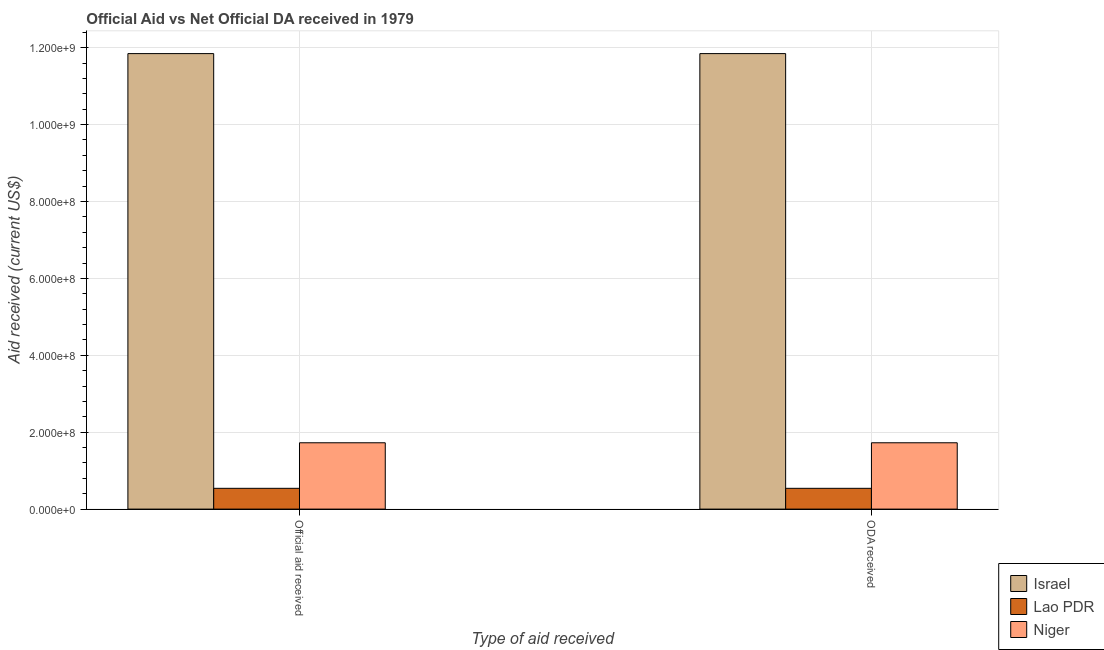How many different coloured bars are there?
Your answer should be compact. 3. How many groups of bars are there?
Your answer should be compact. 2. Are the number of bars per tick equal to the number of legend labels?
Ensure brevity in your answer.  Yes. How many bars are there on the 1st tick from the right?
Your answer should be very brief. 3. What is the label of the 2nd group of bars from the left?
Ensure brevity in your answer.  ODA received. What is the oda received in Lao PDR?
Give a very brief answer. 5.40e+07. Across all countries, what is the maximum official aid received?
Your response must be concise. 1.18e+09. Across all countries, what is the minimum official aid received?
Your answer should be compact. 5.40e+07. In which country was the official aid received maximum?
Give a very brief answer. Israel. In which country was the official aid received minimum?
Your response must be concise. Lao PDR. What is the total oda received in the graph?
Your answer should be compact. 1.41e+09. What is the difference between the oda received in Israel and that in Niger?
Your answer should be compact. 1.01e+09. What is the difference between the oda received in Israel and the official aid received in Niger?
Offer a very short reply. 1.01e+09. What is the average oda received per country?
Offer a very short reply. 4.70e+08. What is the ratio of the oda received in Niger to that in Israel?
Provide a succinct answer. 0.15. Is the oda received in Niger less than that in Lao PDR?
Your response must be concise. No. What does the 2nd bar from the right in Official aid received represents?
Keep it short and to the point. Lao PDR. Are all the bars in the graph horizontal?
Your answer should be very brief. No. Are the values on the major ticks of Y-axis written in scientific E-notation?
Keep it short and to the point. Yes. Does the graph contain grids?
Your answer should be compact. Yes. How are the legend labels stacked?
Keep it short and to the point. Vertical. What is the title of the graph?
Provide a short and direct response. Official Aid vs Net Official DA received in 1979 . What is the label or title of the X-axis?
Give a very brief answer. Type of aid received. What is the label or title of the Y-axis?
Your answer should be compact. Aid received (current US$). What is the Aid received (current US$) of Israel in Official aid received?
Ensure brevity in your answer.  1.18e+09. What is the Aid received (current US$) in Lao PDR in Official aid received?
Keep it short and to the point. 5.40e+07. What is the Aid received (current US$) in Niger in Official aid received?
Offer a terse response. 1.73e+08. What is the Aid received (current US$) in Israel in ODA received?
Keep it short and to the point. 1.18e+09. What is the Aid received (current US$) in Lao PDR in ODA received?
Ensure brevity in your answer.  5.40e+07. What is the Aid received (current US$) of Niger in ODA received?
Keep it short and to the point. 1.73e+08. Across all Type of aid received, what is the maximum Aid received (current US$) of Israel?
Provide a short and direct response. 1.18e+09. Across all Type of aid received, what is the maximum Aid received (current US$) of Lao PDR?
Offer a very short reply. 5.40e+07. Across all Type of aid received, what is the maximum Aid received (current US$) of Niger?
Your answer should be very brief. 1.73e+08. Across all Type of aid received, what is the minimum Aid received (current US$) of Israel?
Make the answer very short. 1.18e+09. Across all Type of aid received, what is the minimum Aid received (current US$) of Lao PDR?
Your response must be concise. 5.40e+07. Across all Type of aid received, what is the minimum Aid received (current US$) in Niger?
Your answer should be compact. 1.73e+08. What is the total Aid received (current US$) in Israel in the graph?
Offer a terse response. 2.37e+09. What is the total Aid received (current US$) in Lao PDR in the graph?
Ensure brevity in your answer.  1.08e+08. What is the total Aid received (current US$) in Niger in the graph?
Give a very brief answer. 3.45e+08. What is the difference between the Aid received (current US$) of Israel in Official aid received and the Aid received (current US$) of Lao PDR in ODA received?
Offer a terse response. 1.13e+09. What is the difference between the Aid received (current US$) of Israel in Official aid received and the Aid received (current US$) of Niger in ODA received?
Make the answer very short. 1.01e+09. What is the difference between the Aid received (current US$) in Lao PDR in Official aid received and the Aid received (current US$) in Niger in ODA received?
Your answer should be very brief. -1.18e+08. What is the average Aid received (current US$) in Israel per Type of aid received?
Offer a terse response. 1.18e+09. What is the average Aid received (current US$) in Lao PDR per Type of aid received?
Give a very brief answer. 5.40e+07. What is the average Aid received (current US$) in Niger per Type of aid received?
Your answer should be compact. 1.73e+08. What is the difference between the Aid received (current US$) in Israel and Aid received (current US$) in Lao PDR in Official aid received?
Your answer should be very brief. 1.13e+09. What is the difference between the Aid received (current US$) of Israel and Aid received (current US$) of Niger in Official aid received?
Offer a very short reply. 1.01e+09. What is the difference between the Aid received (current US$) of Lao PDR and Aid received (current US$) of Niger in Official aid received?
Make the answer very short. -1.18e+08. What is the difference between the Aid received (current US$) in Israel and Aid received (current US$) in Lao PDR in ODA received?
Make the answer very short. 1.13e+09. What is the difference between the Aid received (current US$) in Israel and Aid received (current US$) in Niger in ODA received?
Provide a succinct answer. 1.01e+09. What is the difference between the Aid received (current US$) in Lao PDR and Aid received (current US$) in Niger in ODA received?
Offer a terse response. -1.18e+08. What is the difference between the highest and the second highest Aid received (current US$) in Israel?
Offer a terse response. 0. What is the difference between the highest and the lowest Aid received (current US$) in Lao PDR?
Provide a short and direct response. 0. 